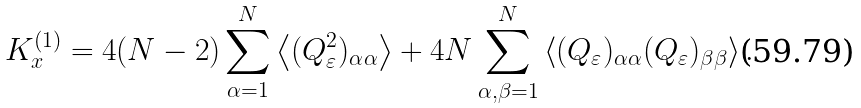Convert formula to latex. <formula><loc_0><loc_0><loc_500><loc_500>K _ { x } ^ { ( 1 ) } = 4 ( N - 2 ) \sum _ { \alpha = 1 } ^ { N } \left \langle ( Q _ { \varepsilon } ^ { 2 } ) _ { \alpha \alpha } \right \rangle + 4 N \sum _ { \alpha , \beta = 1 } ^ { N } \left \langle ( Q _ { \varepsilon } ) _ { \alpha \alpha } ( Q _ { \varepsilon } ) _ { \beta \beta } \right \rangle .</formula> 